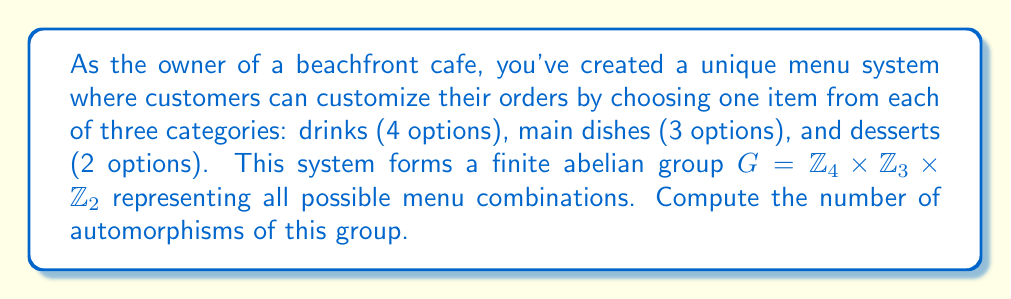Provide a solution to this math problem. To solve this problem, we'll follow these steps:

1) First, recall that for a finite abelian group $G = \mathbb{Z}_{n_1} \times \mathbb{Z}_{n_2} \times ... \times \mathbb{Z}_{n_k}$, the number of automorphisms is given by the formula:

   $$|\text{Aut}(G)| = |\text{GL}(a_1, p_1)| \cdot |\text{GL}(a_2, p_2)| \cdot ... \cdot |\text{GL}(a_m, p_m)| \cdot \prod_{i < j} p_i^{a_i a_j}$$

   where $p_1, p_2, ..., p_m$ are the distinct prime factors of the order of G, and $a_i$ is the number of cyclic factors whose order is divisible by $p_i$.

2) In our case, $G = \mathbb{Z}_4 \times \mathbb{Z}_3 \times \mathbb{Z}_2$. The order of G is $4 \cdot 3 \cdot 2 = 24$.

3) The prime factors are 2 and 3. We have:
   - $p_1 = 2$, $a_1 = 2$ (both $\mathbb{Z}_4$ and $\mathbb{Z}_2$ are divisible by 2)
   - $p_2 = 3$, $a_2 = 1$ (only $\mathbb{Z}_3$ is divisible by 3)

4) Now, we need to calculate:
   - $|\text{GL}(2, 2)|$: This is the number of invertible 2x2 matrices over $\mathbb{Z}_2$, which is $(2^2 - 1)(2^2 - 2) = 6$
   - $|\text{GL}(1, 3)|$: This is simply $\phi(3) = 2$, where $\phi$ is Euler's totient function

5) Finally, we need to calculate $2^{2 \cdot 1} = 2^2 = 4$ for the last term in the product.

6) Putting it all together:

   $$|\text{Aut}(G)| = |\text{GL}(2, 2)| \cdot |\text{GL}(1, 3)| \cdot 2^{2 \cdot 1} = 6 \cdot 2 \cdot 4 = 48$$

Therefore, the group G has 48 automorphisms.
Answer: The number of automorphisms of the group $G = \mathbb{Z}_4 \times \mathbb{Z}_3 \times \mathbb{Z}_2$ is 48. 